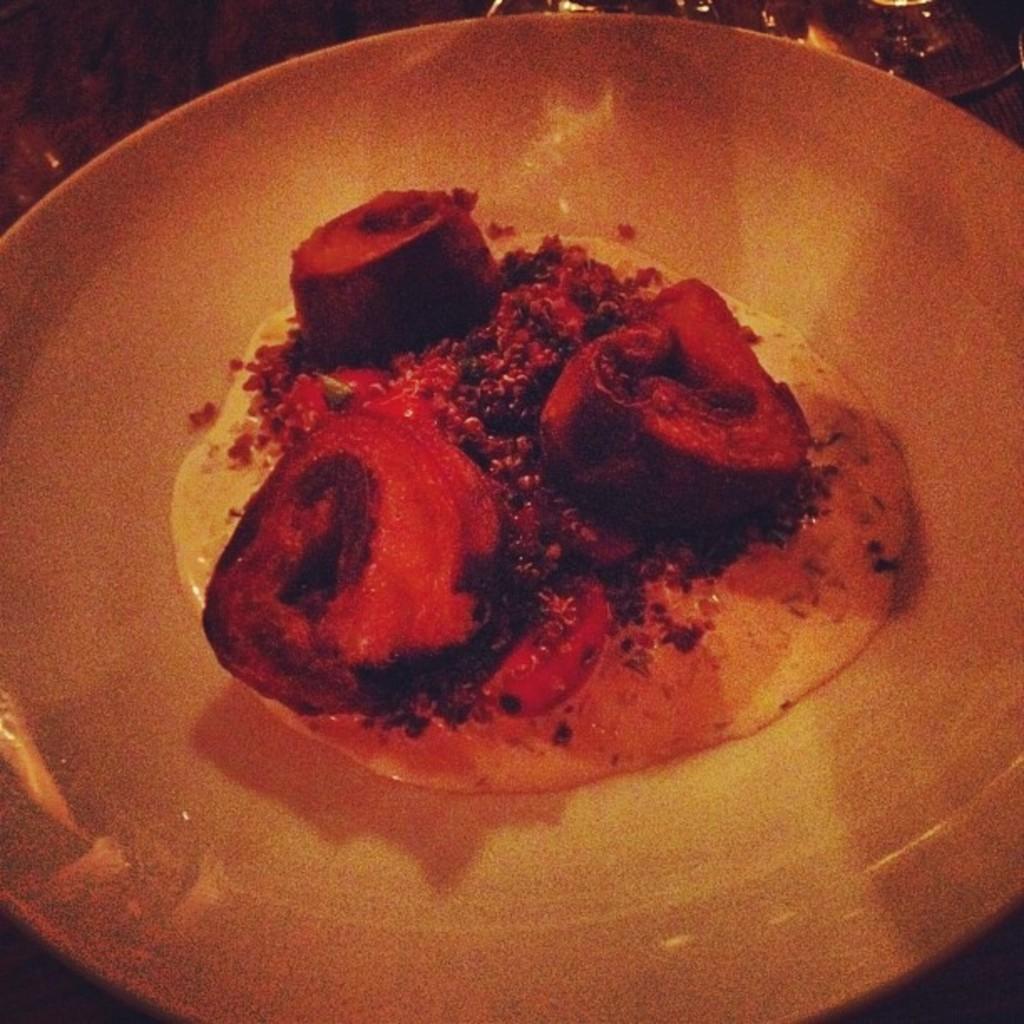Describe this image in one or two sentences. In the image we can see a plate, in the plate there is food. Behind the plate there are some glasses. 